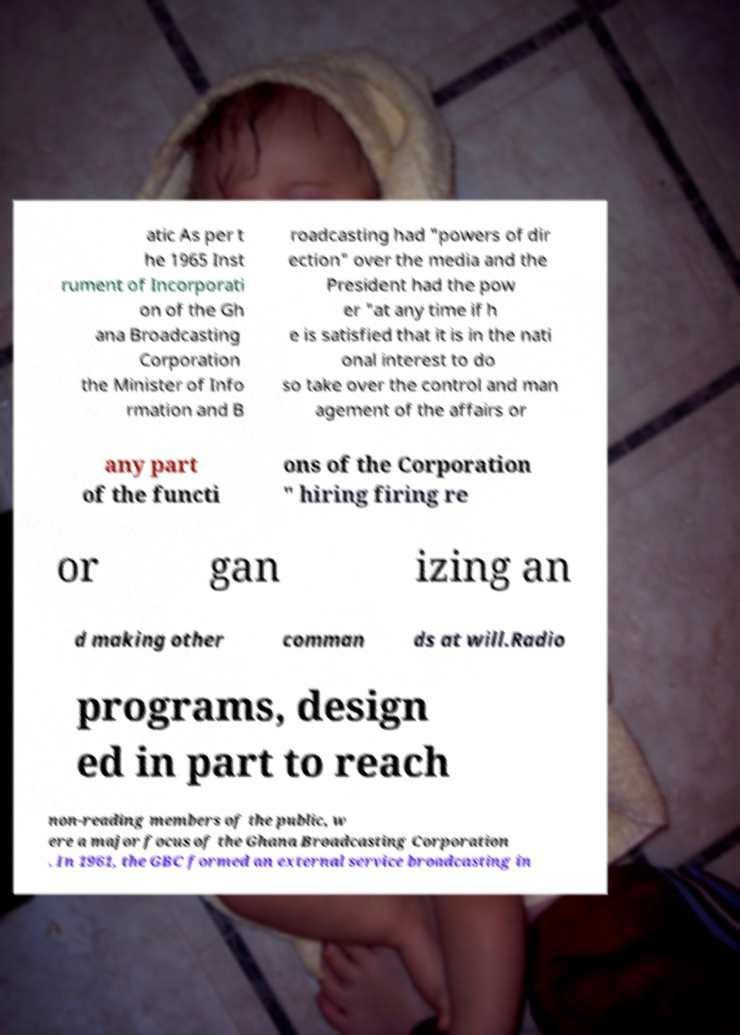What messages or text are displayed in this image? I need them in a readable, typed format. atic As per t he 1965 Inst rument of Incorporati on of the Gh ana Broadcasting Corporation the Minister of Info rmation and B roadcasting had "powers of dir ection" over the media and the President had the pow er "at any time if h e is satisfied that it is in the nati onal interest to do so take over the control and man agement of the affairs or any part of the functi ons of the Corporation " hiring firing re or gan izing an d making other comman ds at will.Radio programs, design ed in part to reach non-reading members of the public, w ere a major focus of the Ghana Broadcasting Corporation . In 1961, the GBC formed an external service broadcasting in 